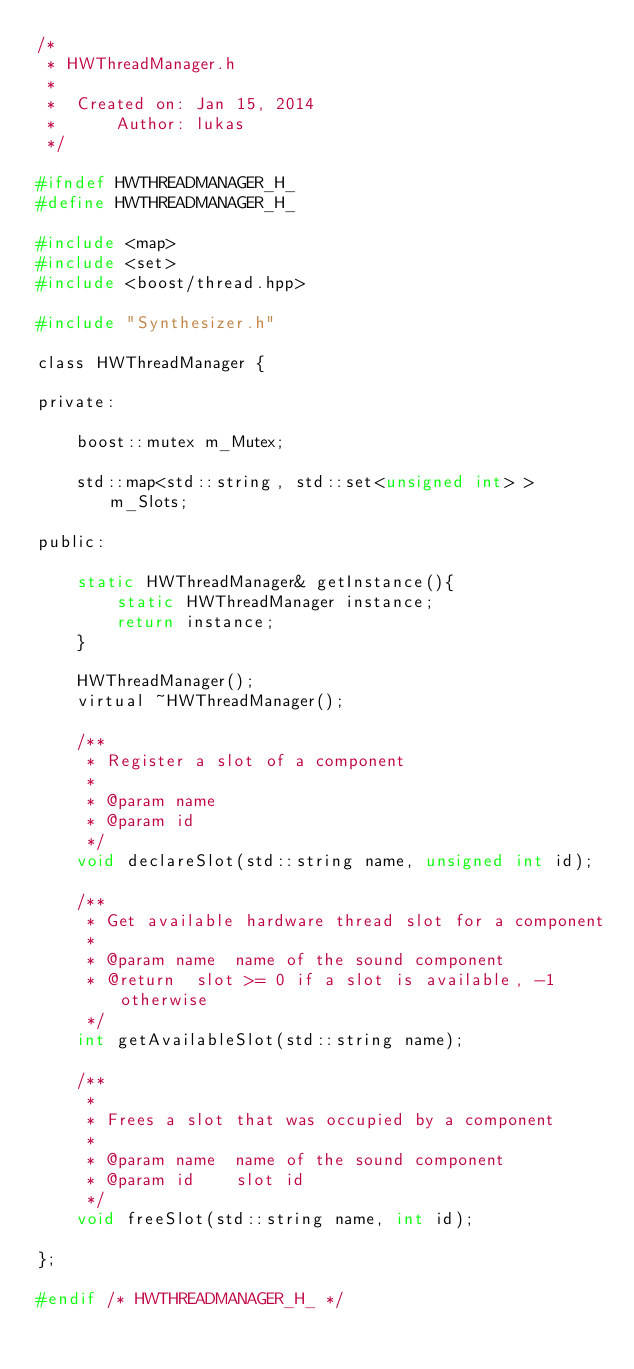Convert code to text. <code><loc_0><loc_0><loc_500><loc_500><_C_>/*
 * HWThreadManager.h
 *
 *  Created on: Jan 15, 2014
 *      Author: lukas
 */

#ifndef HWTHREADMANAGER_H_
#define HWTHREADMANAGER_H_

#include <map>
#include <set>
#include <boost/thread.hpp>

#include "Synthesizer.h"

class HWThreadManager {

private:

    boost::mutex m_Mutex;

    std::map<std::string, std::set<unsigned int> > m_Slots;

public:

    static HWThreadManager& getInstance(){
        static HWThreadManager instance;
        return instance;
    }

    HWThreadManager();
    virtual ~HWThreadManager();

    /**
     * Register a slot of a component
     *
     * @param name
     * @param id
     */
    void declareSlot(std::string name, unsigned int id);

    /**
     * Get available hardware thread slot for a component
     *
     * @param name  name of the sound component
     * @return  slot >= 0 if a slot is available, -1 otherwise
     */
    int getAvailableSlot(std::string name);

    /**
     *
     * Frees a slot that was occupied by a component
     *
     * @param name  name of the sound component
     * @param id    slot id
     */
    void freeSlot(std::string name, int id);

};

#endif /* HWTHREADMANAGER_H_ */
</code> 